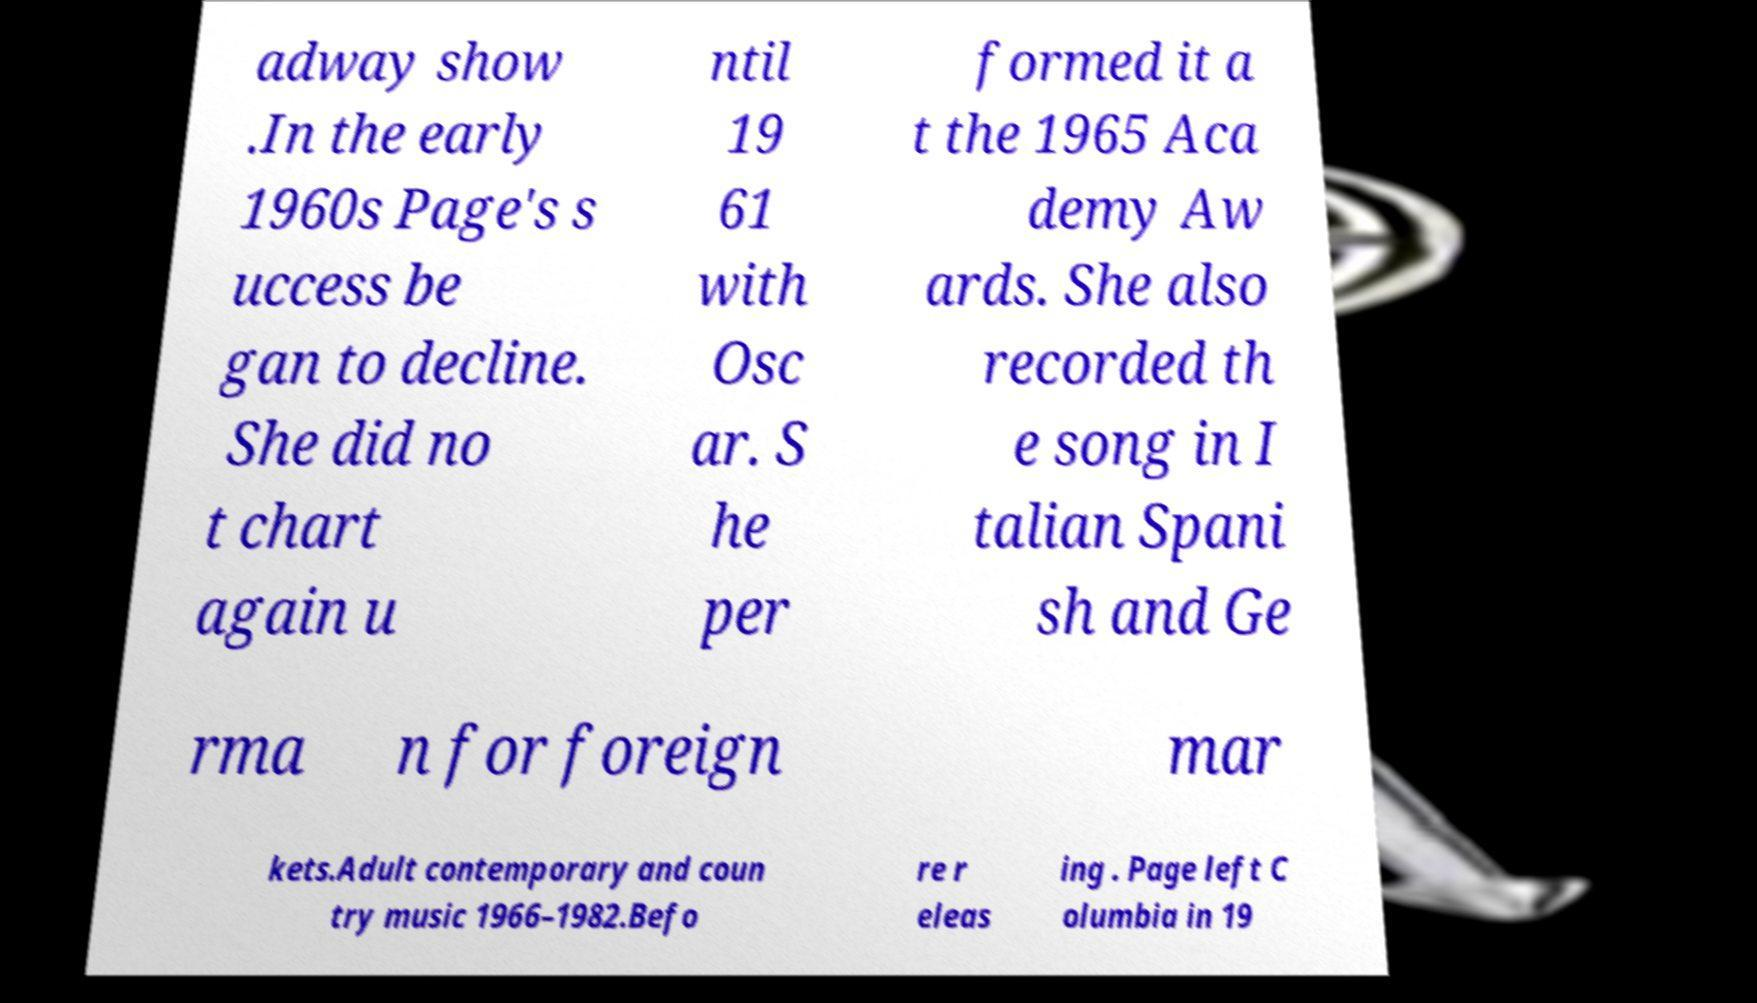What messages or text are displayed in this image? I need them in a readable, typed format. adway show .In the early 1960s Page's s uccess be gan to decline. She did no t chart again u ntil 19 61 with Osc ar. S he per formed it a t the 1965 Aca demy Aw ards. She also recorded th e song in I talian Spani sh and Ge rma n for foreign mar kets.Adult contemporary and coun try music 1966–1982.Befo re r eleas ing . Page left C olumbia in 19 